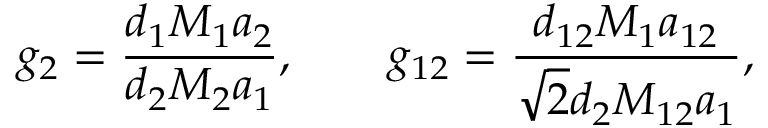Convert formula to latex. <formula><loc_0><loc_0><loc_500><loc_500>g _ { 2 } = \frac { d _ { 1 } M _ { 1 } a _ { 2 } } { d _ { 2 } M _ { 2 } a _ { 1 } } , \quad g _ { 1 2 } = \frac { d _ { 1 2 } M _ { 1 } a _ { 1 2 } } { \sqrt { 2 } d _ { 2 } M _ { 1 2 } a _ { 1 } } ,</formula> 